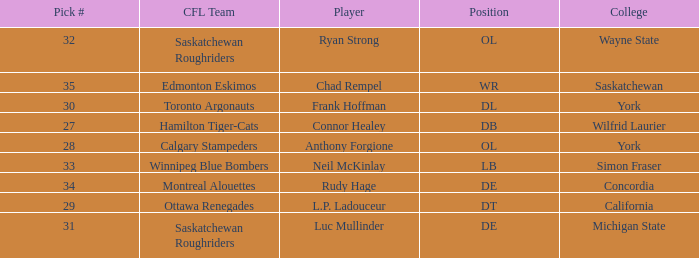What was the highest Pick # for the College of Simon Fraser? 33.0. 